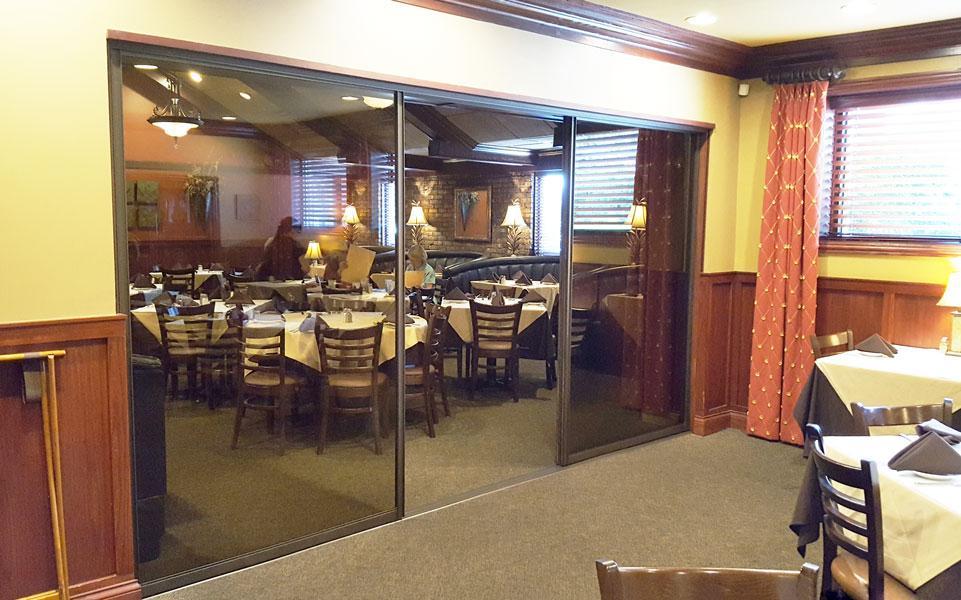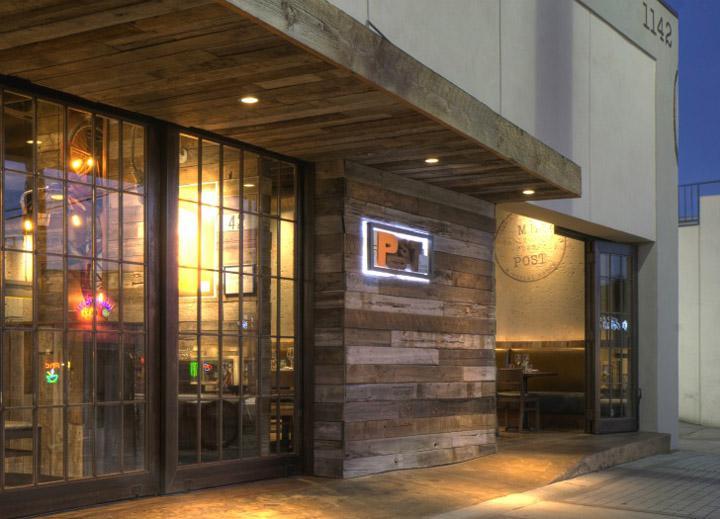The first image is the image on the left, the second image is the image on the right. Assess this claim about the two images: "One image is inside and one is outside.". Correct or not? Answer yes or no. Yes. The first image is the image on the left, the second image is the image on the right. Considering the images on both sides, is "There is a five glass panel and black trim set of doors acorning." valid? Answer yes or no. No. 